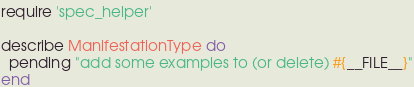<code> <loc_0><loc_0><loc_500><loc_500><_Ruby_>require 'spec_helper'

describe ManifestationType do
  pending "add some examples to (or delete) #{__FILE__}"
end
</code> 